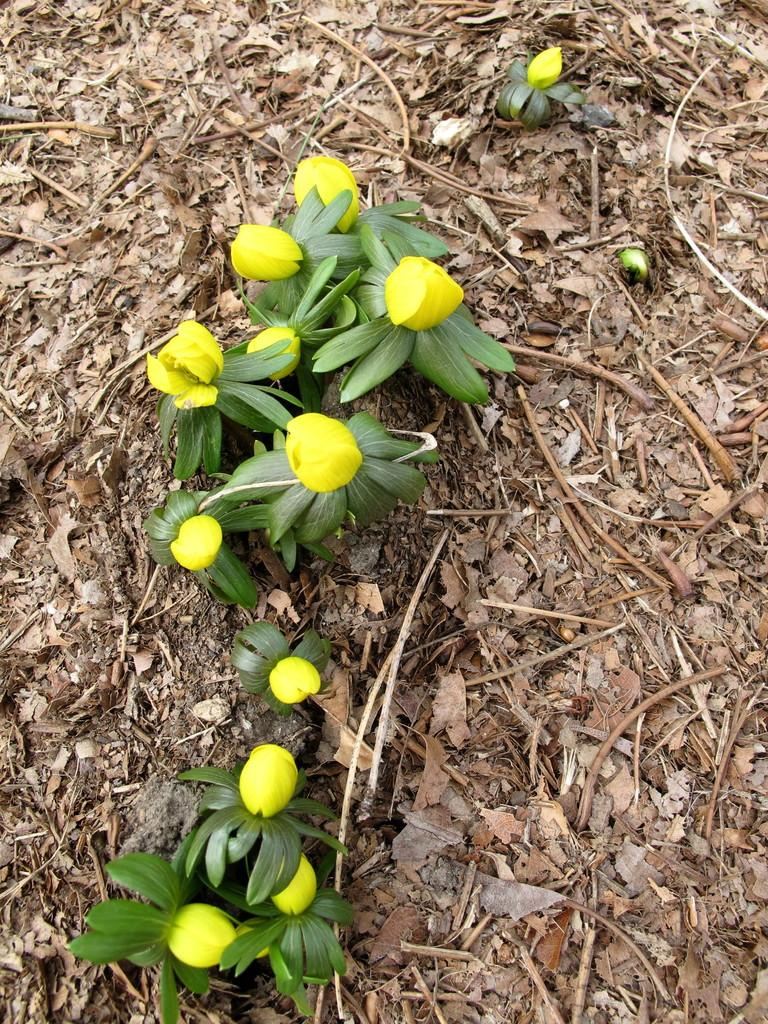What type of plants are in the picture? There are flower plants in the picture. What color are the flowers? The flowers are yellow in color. What else can be seen on the ground in the image? There are other things visible on the ground in the image. How many ladybugs can be seen on the carpenter in the image? There is no carpenter or ladybug present in the image. What are the boys doing in the image? There are no boys present in the image. 